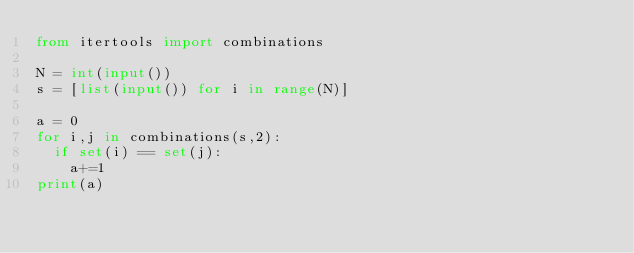Convert code to text. <code><loc_0><loc_0><loc_500><loc_500><_Python_>from itertools import combinations

N = int(input())
s = [list(input()) for i in range(N)]
 
a = 0
for i,j in combinations(s,2):
  if set(i) == set(j):
    a+=1
print(a)</code> 